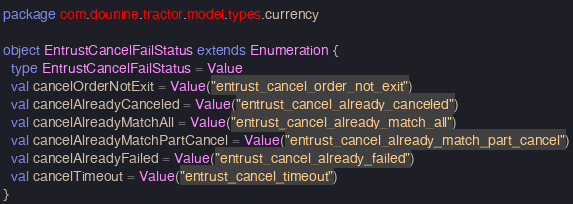<code> <loc_0><loc_0><loc_500><loc_500><_Scala_>package com.dounine.tractor.model.types.currency

object EntrustCancelFailStatus extends Enumeration {
  type EntrustCancelFailStatus = Value
  val cancelOrderNotExit = Value("entrust_cancel_order_not_exit")
  val cancelAlreadyCanceled = Value("entrust_cancel_already_canceled")
  val cancelAlreadyMatchAll = Value("entrust_cancel_already_match_all")
  val cancelAlreadyMatchPartCancel = Value("entrust_cancel_already_match_part_cancel")
  val cancelAlreadyFailed = Value("entrust_cancel_already_failed")
  val cancelTimeout = Value("entrust_cancel_timeout")
}
</code> 